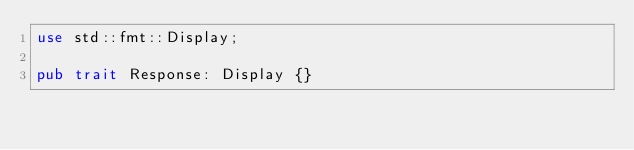<code> <loc_0><loc_0><loc_500><loc_500><_Rust_>use std::fmt::Display;

pub trait Response: Display {}
</code> 